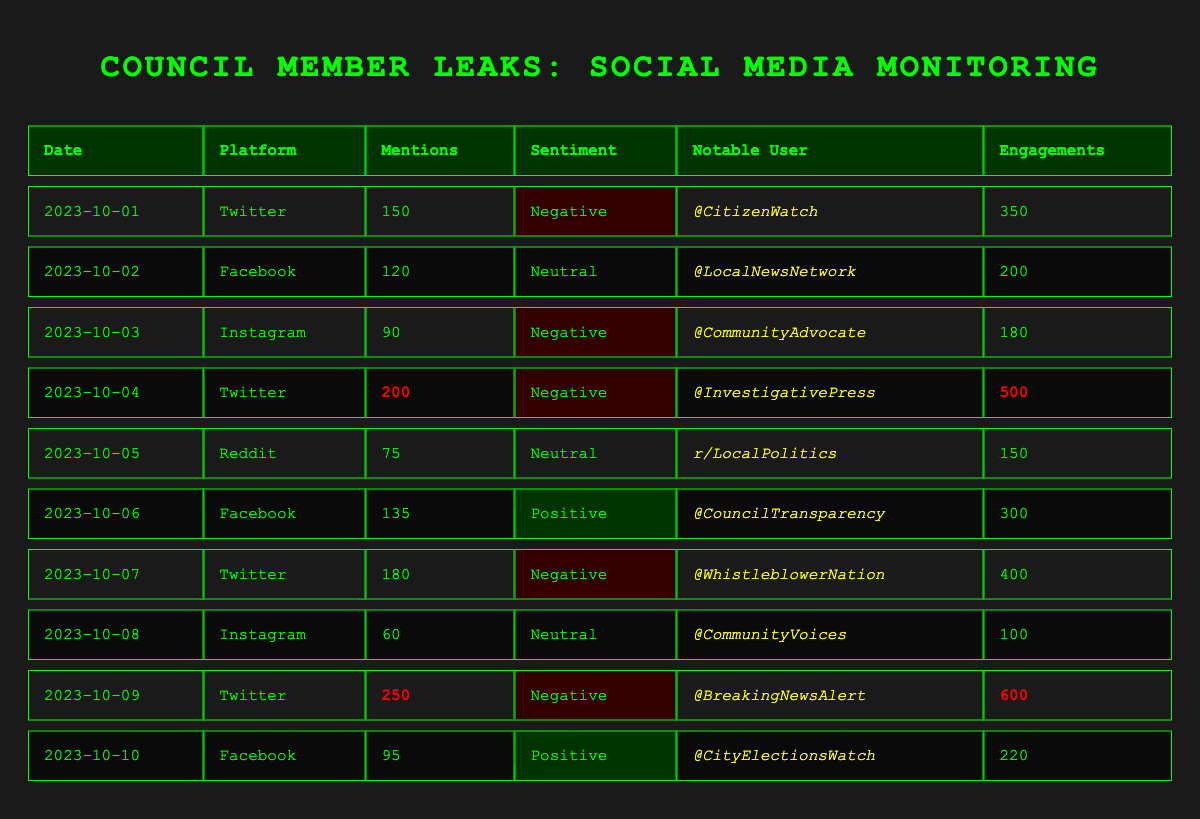What is the total number of mentions across all platforms on October 1st? The table shows that on October 1st, Twitter had 150 mentions. There are no other mentions listed for that date from other platforms, so the total is simply 150.
Answer: 150 Which platform had the highest number of mentions on October 9th? On October 9th, Twitter had 250 mentions, which is the highest number listed for that day, while the other platforms have fewer mentions.
Answer: Twitter What was the average number of engagements for mentions categorized as negative sentiment? The negative sentiment mentions are from Twitter on October 1st (350), October 3rd (180), October 4th (500), October 7th (400), and October 9th (600). Summing these gives 350 + 180 + 500 + 400 + 600 = 2030. Dividing by 5 (the number of entries) gives an average of 406.
Answer: 406 Did any notable user post on Facebook with a positive sentiment? Yes, on October 6th, @CouncilTransparency posted on Facebook with a positive sentiment and 135 mentions.
Answer: Yes What is the total number of mentions from Twitter over the 10 days? The mentions from Twitter are as follows: 150 (Oct 1), 200 (Oct 4), 180 (Oct 7), and 250 (Oct 9). Summing these gives 150 + 200 + 180 + 250 = 780.
Answer: 780 Which notable user had the most engagements, and how many did they receive? The table shows @BreakingNewsAlert on October 9th had the most engagements with a total of 600.
Answer: @BreakingNewsAlert, 600 On which date did @LocalNewsNetwork mention the leaks, and what was the sentiment of their mention? @LocalNewsNetwork mentioned the leaks on October 2nd, and the sentiment of their mention was neutral.
Answer: October 2nd, Neutral How many more mentions did Twitter have compared to Instagram on October 3rd? On October 3rd, Twitter had 90 mentions (which is from Instagram), while Instagram had 90 mentions, making them equal. Hence, there is no difference.
Answer: 0 Across which two days was there an increase in mentions on Facebook, and what was the overall change? On October 6th, mentions on Facebook increased to 135 from 120 on October 2nd. The overall change is an increase of 15 mentions.
Answer: October 2nd to October 6th, +15 Is it true that the maximum engagements came from a post with a negative sentiment? Yes, the maximum engagements (600) came from a post on October 9th with negative sentiment by @BreakingNewsAlert.
Answer: Yes 